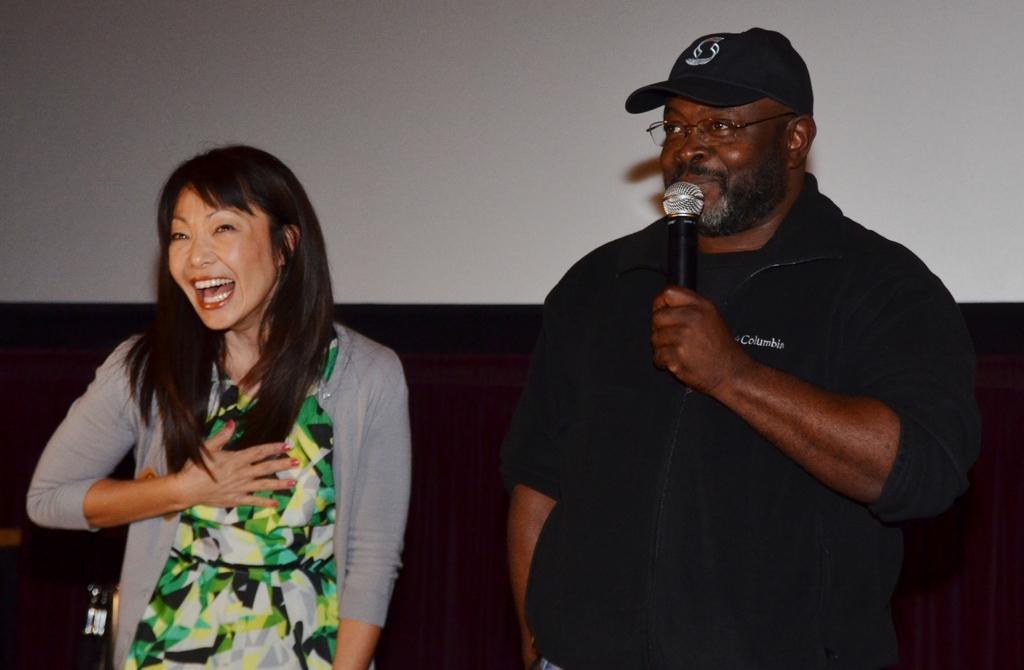How would you summarize this image in a sentence or two? On the right a man is standing and speaking in the microphone in the left a girl is standing and laughing. 